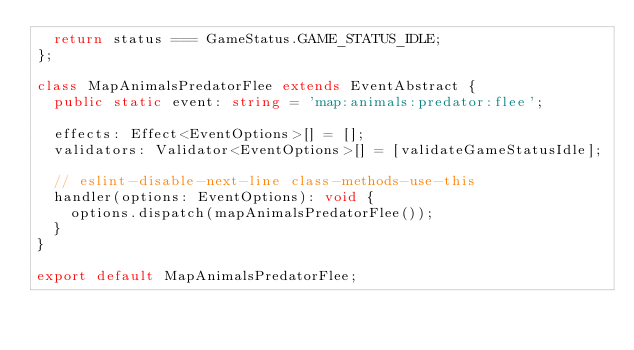<code> <loc_0><loc_0><loc_500><loc_500><_TypeScript_>  return status === GameStatus.GAME_STATUS_IDLE;
};

class MapAnimalsPredatorFlee extends EventAbstract {
  public static event: string = 'map:animals:predator:flee';

  effects: Effect<EventOptions>[] = [];
  validators: Validator<EventOptions>[] = [validateGameStatusIdle];

  // eslint-disable-next-line class-methods-use-this
  handler(options: EventOptions): void {
    options.dispatch(mapAnimalsPredatorFlee());
  }
}

export default MapAnimalsPredatorFlee;
</code> 